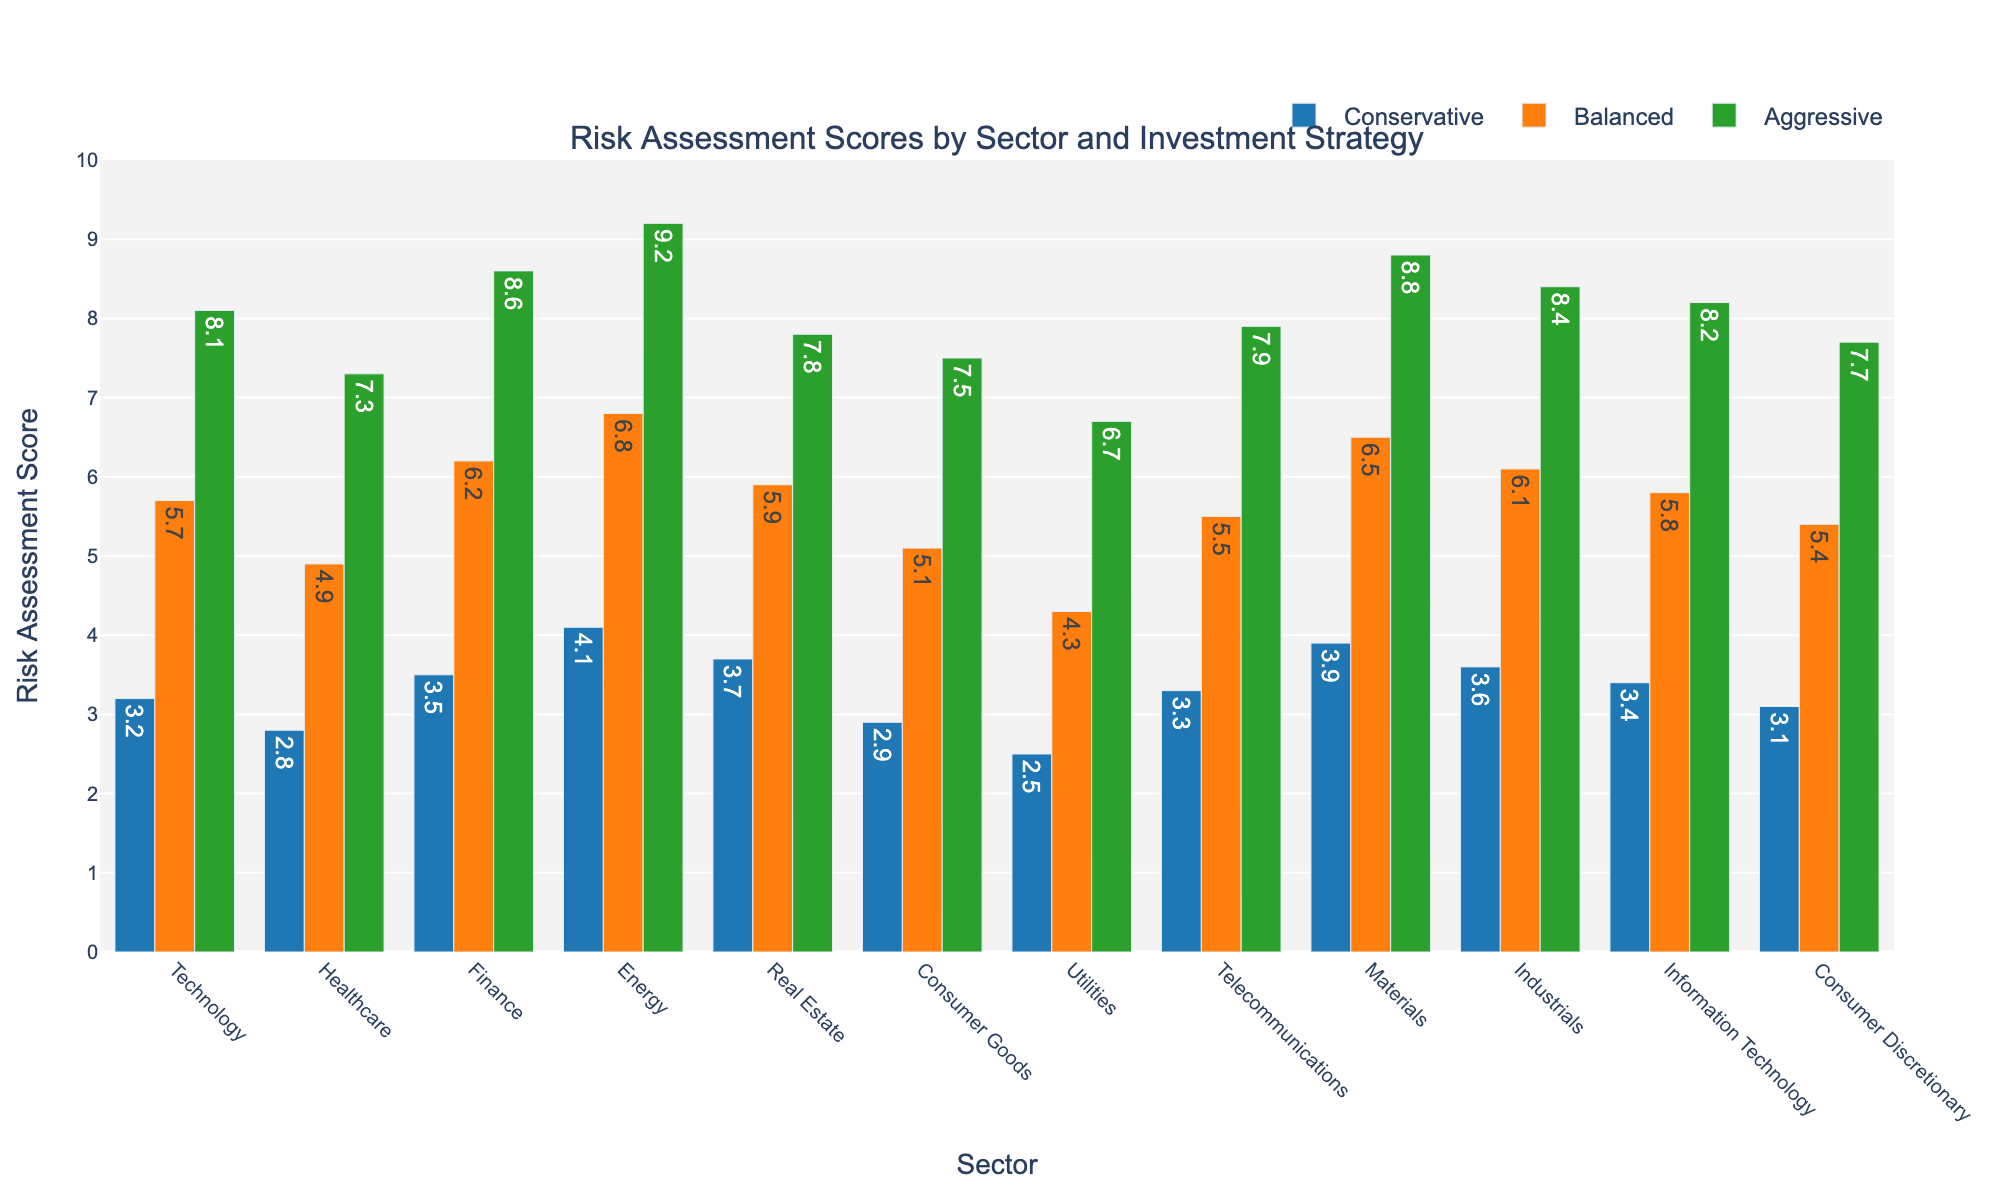What sector has the highest risk assessment score in the Aggressive strategy? The Aggressive strategy scores for each sector are compared. Energy scores the highest with a value of 9.2.
Answer: Energy Which sectors have a conservative risk assessment score of 3.5 or higher? We compare the Conservative scores: Finance (3.5), Energy (4.1), Real Estate (3.7), and Materials (3.9) all meet this criterion.
Answer: Finance, Energy, Real Estate, Materials Compare the Balanced risk assessment score between the Technology and Healthcare sectors. Which is higher and by how much? Technology has a score of 5.7, while Healthcare has 4.9. The difference is 5.7 - 4.9 = 0.8. Technology is higher by 0.8.
Answer: Technology, 0.8 What is the average Aggressive risk assessment score for the Telecommunications, Materials, and Industrials sectors? Adding the Aggressive scores of Telecommunications (7.9), Materials (8.8), and Industrials (8.4): (7.9 + 8.8 + 8.4) / 3 = 25.1 / 3 = 8.37.
Answer: 8.37 In which sector is the difference between Conservative and Aggressive risk assessment scores the largest? The differences for each sector are: 
Technology: 8.1 - 3.2 = 4.9 
Healthcare: 7.3 - 2.8 = 4.5 
Finance: 8.6 - 3.5 = 5.1 
Energy: 9.2 - 4.1 = 5.1 
Real Estate: 7.8 - 3.7 = 4.1 
Consumer Goods: 7.5 - 2.9 = 4.6 
Utilities: 6.7 - 2.5 = 4.2 
Telecommunications: 7.9 - 3.3 = 4.6 
Materials: 8.8 - 3.9 = 4.9 
Industrials: 8.4 - 3.6 = 4.8 
Information Technology: 8.2 - 3.4 = 4.8 
Consumer Discretionary: 7.7 - 3.1 = 4.6 
Finance and Energy both have the largest difference of 5.1.
Answer: Finance, Energy What is the median Balanced risk assessment score across all sectors? The Balanced scores are: 5.7, 4.9, 6.2, 6.8, 5.9, 5.1, 4.3, 5.5, 6.5, 6.1, 5.8, 5.4. Ordered: 4.3, 4.9, 5.1, 5.4, 5.5, 5.7, 5.8, 5.9, 6.1, 6.2, 6.5, 6.8. Median (middle value) is (5.7 + 5.8) / 2 = 5.75.
Answer: 5.75 How does the risk assessment score for Balanced strategy in the Consumer Goods sector visually compare to the Aggressive strategy in the same sector? The Balanced score for Consumer Goods is around half the height of the Aggressive score, indicating that the Aggressive score (7.5) is much higher compared to the Balanced score (5.1).
Answer: Lower Which investment strategy generally has the lowest risk assessment scores across all sectors? Comparing all three strategies: Conservative generally has the lower values compared to Balanced and Aggressive.
Answer: Conservative 